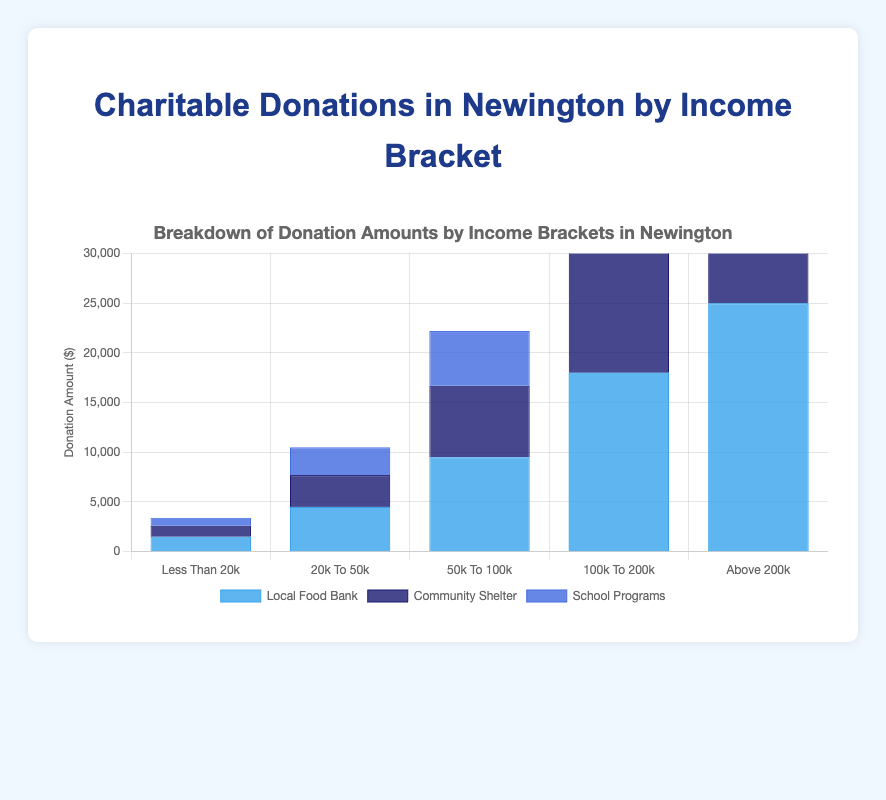Which income bracket gave the most to the Community Shelter? By looking at the height of the dark blue bars, the "above 200k" income bracket donated the most to the Community Shelter, totaling 21000.
Answer: Above 200k Which organization received the most donations from the "20k to 50k" income bracket? By comparing the bar heights for the "20k to 50k" bracket, the local food bank received the highest donation of 4500.
Answer: Local Food Bank How much more did the "50k to 100k" income bracket donate to school programs than the "less than 20k" income bracket? The "50k to 100k" income bracket donated 5500 to school programs, while the "less than 20k" income bracket donated 800. The difference is 5500 - 800, which equals 4700.
Answer: 4700 What is the total amount donated to the Local Food Bank by all income brackets? Summing up the donations to the Local Food Bank across all income brackets: 1500 + 4500 + 9500 + 18000 + 25000 equals 58500.
Answer: 58500 Which income bracket has the least total donations across all organizations? By summing the donations for each income bracket, the least is for "less than 20k": 1500 + 1100 + 800 equals 3400.
Answer: Less than 20k Compare the donations to the Community Shelter and School Programs for the "100k to 200k" income bracket. Which is greater? For "100k to 200k" income bracket, the Community Shelter received 13500 while School Programs received 11500. Therefore, Community Shelter received more.
Answer: Community Shelter Which organization received the least donations from the "above 200k" income bracket? The shortest bar for the "above 200k" income bracket corresponds to School Programs, which received 19500.
Answer: School Programs 